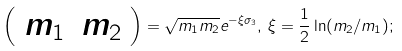<formula> <loc_0><loc_0><loc_500><loc_500>\left ( \begin{array} { c c } { { m _ { 1 } } } & { { m _ { 2 } } } \end{array} \right ) = \sqrt { m _ { 1 } m _ { 2 } } e ^ { - \xi \sigma _ { 3 } } , \, \xi = \frac { 1 } { 2 } \ln ( m _ { 2 } / m _ { 1 } ) ;</formula> 